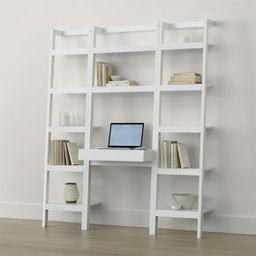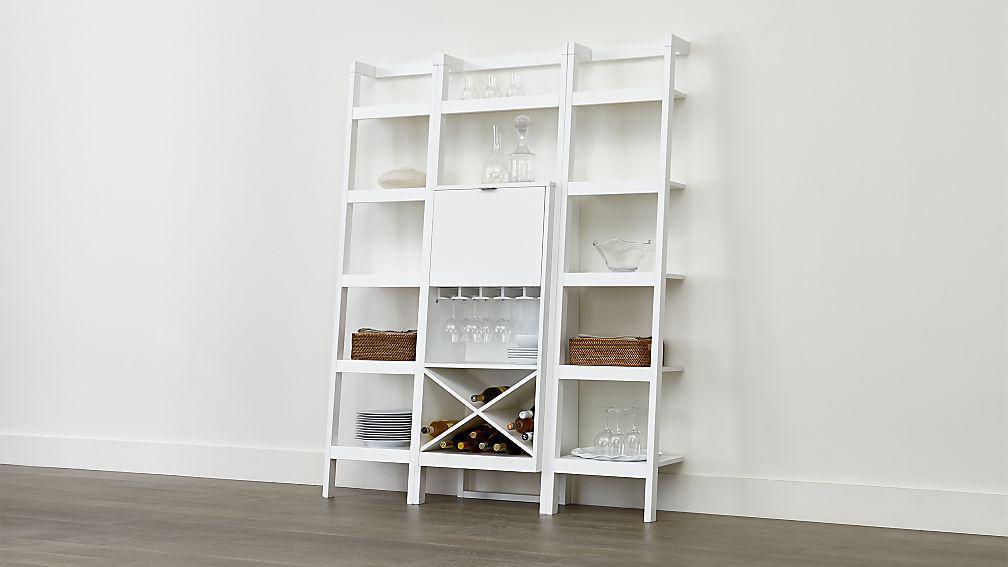The first image is the image on the left, the second image is the image on the right. Assess this claim about the two images: "There are atleast 2 large bookshelves". Correct or not? Answer yes or no. Yes. 